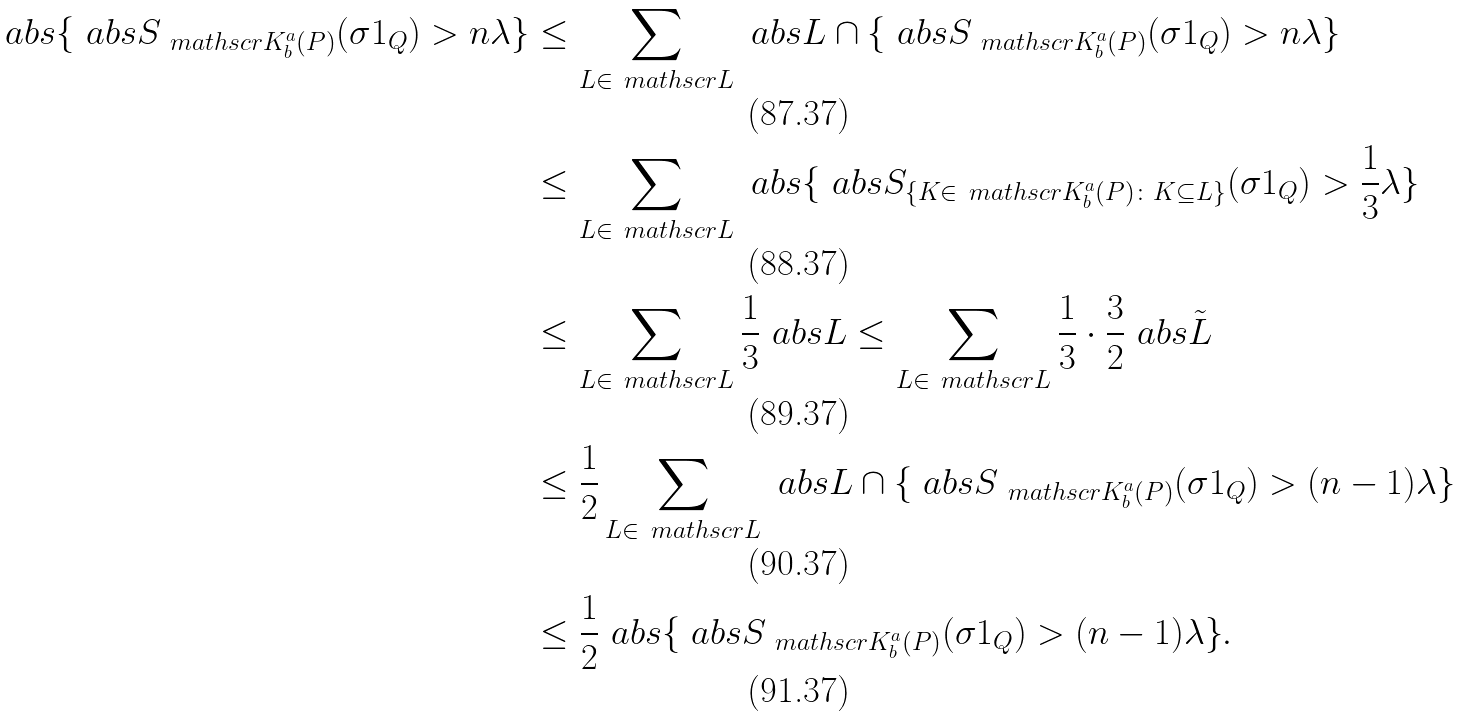<formula> <loc_0><loc_0><loc_500><loc_500>\ a b s { \{ \ a b s { S _ { \ m a t h s c r { K } ^ { a } _ { b } ( P ) } ( \sigma 1 _ { Q } ) } > n \lambda \} } & \leq \sum _ { L \in \ m a t h s c r { L } } \ a b s { L \cap \{ \ a b s { S _ { \ m a t h s c r { K } ^ { a } _ { b } ( P ) } ( \sigma 1 _ { Q } ) } > n \lambda \} } \\ & \leq \sum _ { L \in \ m a t h s c r { L } } \ a b s { \{ \ a b s { S _ { \{ K \in \ m a t h s c r { K } ^ { a } _ { b } ( P ) \colon K \subseteq L \} } ( \sigma 1 _ { Q } ) } > \frac { 1 } { 3 } \lambda \} } \\ & \leq \sum _ { L \in \ m a t h s c r { L } } \frac { 1 } { 3 } \ a b s { L } \leq \sum _ { L \in \ m a t h s c r { L } } \frac { 1 } { 3 } \cdot \frac { 3 } { 2 } \ a b s { \tilde { L } } \\ & \leq \frac { 1 } { 2 } \sum _ { L \in \ m a t h s c r { L } } \ a b s { L \cap \{ \ a b s { S _ { \ m a t h s c r { K } ^ { a } _ { b } ( P ) } ( \sigma 1 _ { Q } ) } > ( n - 1 ) \lambda \} } \\ & \leq \frac { 1 } { 2 } \ a b s { \{ \ a b s { S _ { \ m a t h s c r { K } ^ { a } _ { b } ( P ) } ( \sigma 1 _ { Q } ) } > ( n - 1 ) \lambda \} } .</formula> 